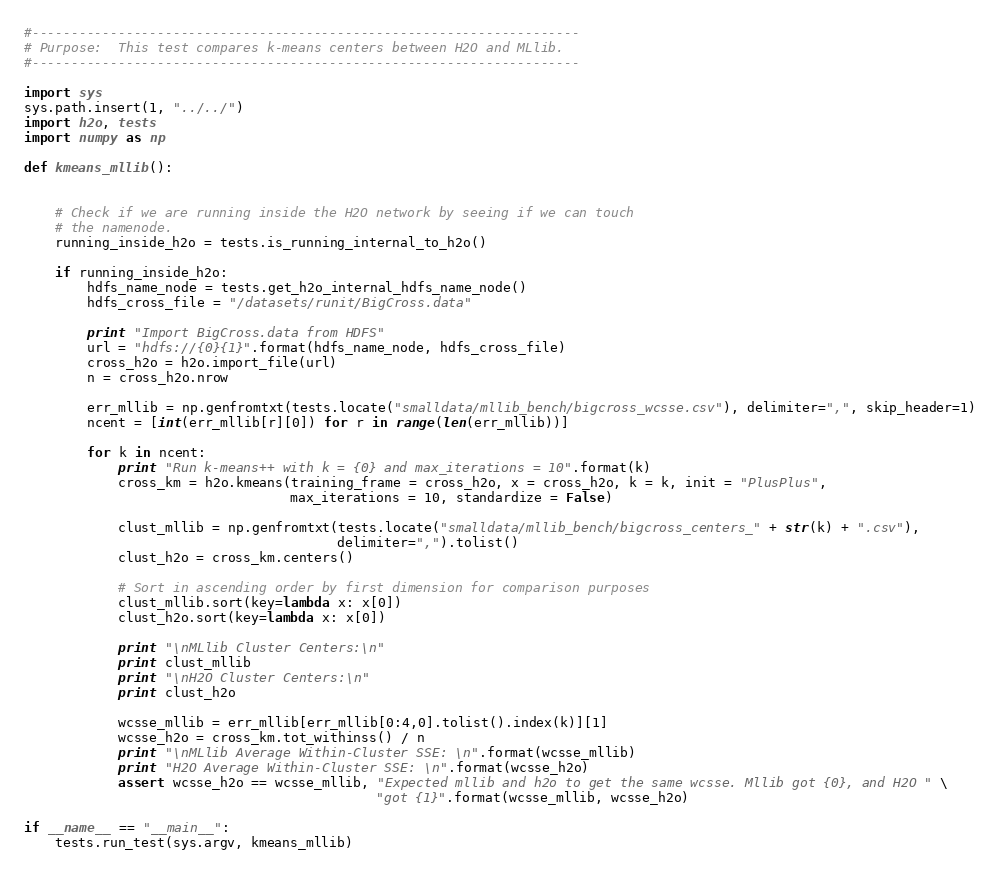<code> <loc_0><loc_0><loc_500><loc_500><_Python_>#----------------------------------------------------------------------
# Purpose:  This test compares k-means centers between H2O and MLlib.
#----------------------------------------------------------------------

import sys
sys.path.insert(1, "../../")
import h2o, tests
import numpy as np

def kmeans_mllib():
    

    # Check if we are running inside the H2O network by seeing if we can touch
    # the namenode.
    running_inside_h2o = tests.is_running_internal_to_h2o()

    if running_inside_h2o:
        hdfs_name_node = tests.get_h2o_internal_hdfs_name_node()
        hdfs_cross_file = "/datasets/runit/BigCross.data"

        print "Import BigCross.data from HDFS"
        url = "hdfs://{0}{1}".format(hdfs_name_node, hdfs_cross_file)
        cross_h2o = h2o.import_file(url)
        n = cross_h2o.nrow

        err_mllib = np.genfromtxt(tests.locate("smalldata/mllib_bench/bigcross_wcsse.csv"), delimiter=",", skip_header=1)
        ncent = [int(err_mllib[r][0]) for r in range(len(err_mllib))]

        for k in ncent:
            print "Run k-means++ with k = {0} and max_iterations = 10".format(k)
            cross_km = h2o.kmeans(training_frame = cross_h2o, x = cross_h2o, k = k, init = "PlusPlus",
                                  max_iterations = 10, standardize = False)

            clust_mllib = np.genfromtxt(tests.locate("smalldata/mllib_bench/bigcross_centers_" + str(k) + ".csv"),
                                        delimiter=",").tolist()
            clust_h2o = cross_km.centers()

            # Sort in ascending order by first dimension for comparison purposes
            clust_mllib.sort(key=lambda x: x[0])
            clust_h2o.sort(key=lambda x: x[0])

            print "\nMLlib Cluster Centers:\n"
            print clust_mllib
            print "\nH2O Cluster Centers:\n"
            print clust_h2o

            wcsse_mllib = err_mllib[err_mllib[0:4,0].tolist().index(k)][1]
            wcsse_h2o = cross_km.tot_withinss() / n
            print "\nMLlib Average Within-Cluster SSE: \n".format(wcsse_mllib)
            print "H2O Average Within-Cluster SSE: \n".format(wcsse_h2o)
            assert wcsse_h2o == wcsse_mllib, "Expected mllib and h2o to get the same wcsse. Mllib got {0}, and H2O " \
                                             "got {1}".format(wcsse_mllib, wcsse_h2o)

if __name__ == "__main__":
    tests.run_test(sys.argv, kmeans_mllib)
</code> 